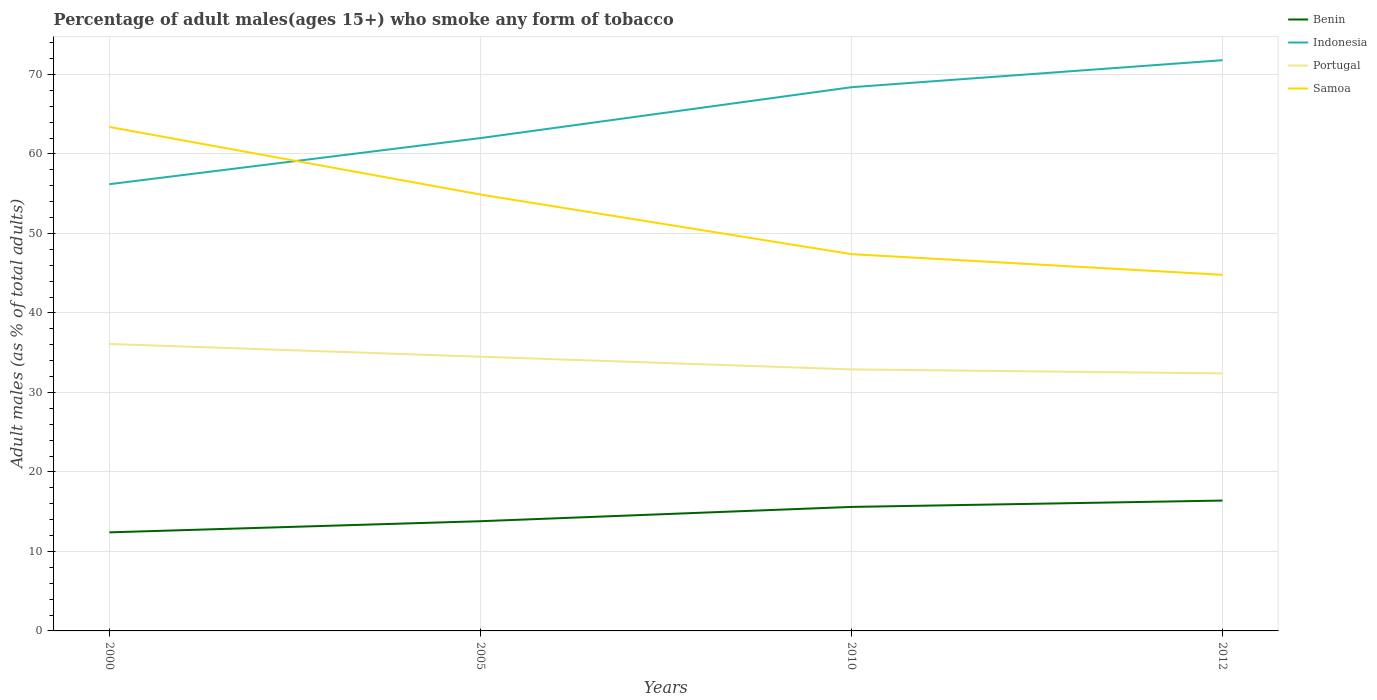Does the line corresponding to Portugal intersect with the line corresponding to Samoa?
Your response must be concise. No. Is the number of lines equal to the number of legend labels?
Your answer should be very brief. Yes. Across all years, what is the maximum percentage of adult males who smoke in Indonesia?
Offer a terse response. 56.2. In which year was the percentage of adult males who smoke in Benin maximum?
Make the answer very short. 2000. What is the total percentage of adult males who smoke in Indonesia in the graph?
Offer a very short reply. -12.2. What is the difference between the highest and the second highest percentage of adult males who smoke in Samoa?
Provide a short and direct response. 18.6. How many years are there in the graph?
Offer a very short reply. 4. What is the difference between two consecutive major ticks on the Y-axis?
Your answer should be very brief. 10. Are the values on the major ticks of Y-axis written in scientific E-notation?
Your answer should be very brief. No. What is the title of the graph?
Your response must be concise. Percentage of adult males(ages 15+) who smoke any form of tobacco. What is the label or title of the Y-axis?
Ensure brevity in your answer.  Adult males (as % of total adults). What is the Adult males (as % of total adults) in Benin in 2000?
Offer a terse response. 12.4. What is the Adult males (as % of total adults) in Indonesia in 2000?
Keep it short and to the point. 56.2. What is the Adult males (as % of total adults) in Portugal in 2000?
Provide a short and direct response. 36.1. What is the Adult males (as % of total adults) in Samoa in 2000?
Offer a very short reply. 63.4. What is the Adult males (as % of total adults) of Portugal in 2005?
Offer a terse response. 34.5. What is the Adult males (as % of total adults) in Samoa in 2005?
Keep it short and to the point. 54.9. What is the Adult males (as % of total adults) in Benin in 2010?
Provide a short and direct response. 15.6. What is the Adult males (as % of total adults) in Indonesia in 2010?
Give a very brief answer. 68.4. What is the Adult males (as % of total adults) in Portugal in 2010?
Make the answer very short. 32.9. What is the Adult males (as % of total adults) of Samoa in 2010?
Your answer should be compact. 47.4. What is the Adult males (as % of total adults) of Benin in 2012?
Provide a short and direct response. 16.4. What is the Adult males (as % of total adults) of Indonesia in 2012?
Your answer should be very brief. 71.8. What is the Adult males (as % of total adults) of Portugal in 2012?
Provide a succinct answer. 32.4. What is the Adult males (as % of total adults) of Samoa in 2012?
Offer a terse response. 44.8. Across all years, what is the maximum Adult males (as % of total adults) of Benin?
Provide a succinct answer. 16.4. Across all years, what is the maximum Adult males (as % of total adults) in Indonesia?
Keep it short and to the point. 71.8. Across all years, what is the maximum Adult males (as % of total adults) in Portugal?
Your answer should be compact. 36.1. Across all years, what is the maximum Adult males (as % of total adults) of Samoa?
Provide a succinct answer. 63.4. Across all years, what is the minimum Adult males (as % of total adults) in Indonesia?
Your answer should be very brief. 56.2. Across all years, what is the minimum Adult males (as % of total adults) of Portugal?
Keep it short and to the point. 32.4. Across all years, what is the minimum Adult males (as % of total adults) in Samoa?
Your answer should be compact. 44.8. What is the total Adult males (as % of total adults) in Benin in the graph?
Provide a short and direct response. 58.2. What is the total Adult males (as % of total adults) of Indonesia in the graph?
Your answer should be very brief. 258.4. What is the total Adult males (as % of total adults) of Portugal in the graph?
Your response must be concise. 135.9. What is the total Adult males (as % of total adults) in Samoa in the graph?
Offer a terse response. 210.5. What is the difference between the Adult males (as % of total adults) in Portugal in 2000 and that in 2005?
Offer a terse response. 1.6. What is the difference between the Adult males (as % of total adults) of Indonesia in 2000 and that in 2010?
Your response must be concise. -12.2. What is the difference between the Adult males (as % of total adults) in Portugal in 2000 and that in 2010?
Make the answer very short. 3.2. What is the difference between the Adult males (as % of total adults) in Samoa in 2000 and that in 2010?
Your answer should be very brief. 16. What is the difference between the Adult males (as % of total adults) in Benin in 2000 and that in 2012?
Your response must be concise. -4. What is the difference between the Adult males (as % of total adults) of Indonesia in 2000 and that in 2012?
Your answer should be very brief. -15.6. What is the difference between the Adult males (as % of total adults) of Portugal in 2000 and that in 2012?
Ensure brevity in your answer.  3.7. What is the difference between the Adult males (as % of total adults) of Benin in 2005 and that in 2010?
Give a very brief answer. -1.8. What is the difference between the Adult males (as % of total adults) in Portugal in 2005 and that in 2010?
Provide a short and direct response. 1.6. What is the difference between the Adult males (as % of total adults) in Samoa in 2005 and that in 2010?
Offer a terse response. 7.5. What is the difference between the Adult males (as % of total adults) in Benin in 2005 and that in 2012?
Your answer should be compact. -2.6. What is the difference between the Adult males (as % of total adults) of Indonesia in 2005 and that in 2012?
Keep it short and to the point. -9.8. What is the difference between the Adult males (as % of total adults) of Portugal in 2005 and that in 2012?
Your response must be concise. 2.1. What is the difference between the Adult males (as % of total adults) of Samoa in 2005 and that in 2012?
Make the answer very short. 10.1. What is the difference between the Adult males (as % of total adults) in Benin in 2010 and that in 2012?
Your answer should be very brief. -0.8. What is the difference between the Adult males (as % of total adults) of Portugal in 2010 and that in 2012?
Make the answer very short. 0.5. What is the difference between the Adult males (as % of total adults) in Samoa in 2010 and that in 2012?
Your answer should be compact. 2.6. What is the difference between the Adult males (as % of total adults) in Benin in 2000 and the Adult males (as % of total adults) in Indonesia in 2005?
Offer a very short reply. -49.6. What is the difference between the Adult males (as % of total adults) in Benin in 2000 and the Adult males (as % of total adults) in Portugal in 2005?
Give a very brief answer. -22.1. What is the difference between the Adult males (as % of total adults) of Benin in 2000 and the Adult males (as % of total adults) of Samoa in 2005?
Keep it short and to the point. -42.5. What is the difference between the Adult males (as % of total adults) of Indonesia in 2000 and the Adult males (as % of total adults) of Portugal in 2005?
Provide a short and direct response. 21.7. What is the difference between the Adult males (as % of total adults) in Indonesia in 2000 and the Adult males (as % of total adults) in Samoa in 2005?
Keep it short and to the point. 1.3. What is the difference between the Adult males (as % of total adults) of Portugal in 2000 and the Adult males (as % of total adults) of Samoa in 2005?
Offer a terse response. -18.8. What is the difference between the Adult males (as % of total adults) of Benin in 2000 and the Adult males (as % of total adults) of Indonesia in 2010?
Provide a succinct answer. -56. What is the difference between the Adult males (as % of total adults) in Benin in 2000 and the Adult males (as % of total adults) in Portugal in 2010?
Offer a terse response. -20.5. What is the difference between the Adult males (as % of total adults) of Benin in 2000 and the Adult males (as % of total adults) of Samoa in 2010?
Give a very brief answer. -35. What is the difference between the Adult males (as % of total adults) in Indonesia in 2000 and the Adult males (as % of total adults) in Portugal in 2010?
Offer a terse response. 23.3. What is the difference between the Adult males (as % of total adults) in Indonesia in 2000 and the Adult males (as % of total adults) in Samoa in 2010?
Your answer should be very brief. 8.8. What is the difference between the Adult males (as % of total adults) in Benin in 2000 and the Adult males (as % of total adults) in Indonesia in 2012?
Your answer should be very brief. -59.4. What is the difference between the Adult males (as % of total adults) of Benin in 2000 and the Adult males (as % of total adults) of Samoa in 2012?
Your answer should be very brief. -32.4. What is the difference between the Adult males (as % of total adults) of Indonesia in 2000 and the Adult males (as % of total adults) of Portugal in 2012?
Your answer should be compact. 23.8. What is the difference between the Adult males (as % of total adults) in Indonesia in 2000 and the Adult males (as % of total adults) in Samoa in 2012?
Your answer should be compact. 11.4. What is the difference between the Adult males (as % of total adults) in Benin in 2005 and the Adult males (as % of total adults) in Indonesia in 2010?
Offer a very short reply. -54.6. What is the difference between the Adult males (as % of total adults) of Benin in 2005 and the Adult males (as % of total adults) of Portugal in 2010?
Keep it short and to the point. -19.1. What is the difference between the Adult males (as % of total adults) of Benin in 2005 and the Adult males (as % of total adults) of Samoa in 2010?
Make the answer very short. -33.6. What is the difference between the Adult males (as % of total adults) of Indonesia in 2005 and the Adult males (as % of total adults) of Portugal in 2010?
Your answer should be compact. 29.1. What is the difference between the Adult males (as % of total adults) of Indonesia in 2005 and the Adult males (as % of total adults) of Samoa in 2010?
Provide a short and direct response. 14.6. What is the difference between the Adult males (as % of total adults) in Benin in 2005 and the Adult males (as % of total adults) in Indonesia in 2012?
Keep it short and to the point. -58. What is the difference between the Adult males (as % of total adults) in Benin in 2005 and the Adult males (as % of total adults) in Portugal in 2012?
Give a very brief answer. -18.6. What is the difference between the Adult males (as % of total adults) in Benin in 2005 and the Adult males (as % of total adults) in Samoa in 2012?
Offer a very short reply. -31. What is the difference between the Adult males (as % of total adults) in Indonesia in 2005 and the Adult males (as % of total adults) in Portugal in 2012?
Your response must be concise. 29.6. What is the difference between the Adult males (as % of total adults) of Portugal in 2005 and the Adult males (as % of total adults) of Samoa in 2012?
Provide a succinct answer. -10.3. What is the difference between the Adult males (as % of total adults) in Benin in 2010 and the Adult males (as % of total adults) in Indonesia in 2012?
Make the answer very short. -56.2. What is the difference between the Adult males (as % of total adults) in Benin in 2010 and the Adult males (as % of total adults) in Portugal in 2012?
Your answer should be very brief. -16.8. What is the difference between the Adult males (as % of total adults) in Benin in 2010 and the Adult males (as % of total adults) in Samoa in 2012?
Keep it short and to the point. -29.2. What is the difference between the Adult males (as % of total adults) in Indonesia in 2010 and the Adult males (as % of total adults) in Portugal in 2012?
Provide a short and direct response. 36. What is the difference between the Adult males (as % of total adults) in Indonesia in 2010 and the Adult males (as % of total adults) in Samoa in 2012?
Keep it short and to the point. 23.6. What is the average Adult males (as % of total adults) of Benin per year?
Your response must be concise. 14.55. What is the average Adult males (as % of total adults) of Indonesia per year?
Your response must be concise. 64.6. What is the average Adult males (as % of total adults) of Portugal per year?
Ensure brevity in your answer.  33.98. What is the average Adult males (as % of total adults) in Samoa per year?
Provide a succinct answer. 52.62. In the year 2000, what is the difference between the Adult males (as % of total adults) of Benin and Adult males (as % of total adults) of Indonesia?
Provide a succinct answer. -43.8. In the year 2000, what is the difference between the Adult males (as % of total adults) in Benin and Adult males (as % of total adults) in Portugal?
Make the answer very short. -23.7. In the year 2000, what is the difference between the Adult males (as % of total adults) in Benin and Adult males (as % of total adults) in Samoa?
Your answer should be very brief. -51. In the year 2000, what is the difference between the Adult males (as % of total adults) in Indonesia and Adult males (as % of total adults) in Portugal?
Make the answer very short. 20.1. In the year 2000, what is the difference between the Adult males (as % of total adults) in Indonesia and Adult males (as % of total adults) in Samoa?
Offer a terse response. -7.2. In the year 2000, what is the difference between the Adult males (as % of total adults) in Portugal and Adult males (as % of total adults) in Samoa?
Ensure brevity in your answer.  -27.3. In the year 2005, what is the difference between the Adult males (as % of total adults) of Benin and Adult males (as % of total adults) of Indonesia?
Provide a succinct answer. -48.2. In the year 2005, what is the difference between the Adult males (as % of total adults) in Benin and Adult males (as % of total adults) in Portugal?
Your answer should be compact. -20.7. In the year 2005, what is the difference between the Adult males (as % of total adults) of Benin and Adult males (as % of total adults) of Samoa?
Offer a terse response. -41.1. In the year 2005, what is the difference between the Adult males (as % of total adults) in Indonesia and Adult males (as % of total adults) in Samoa?
Offer a terse response. 7.1. In the year 2005, what is the difference between the Adult males (as % of total adults) of Portugal and Adult males (as % of total adults) of Samoa?
Offer a very short reply. -20.4. In the year 2010, what is the difference between the Adult males (as % of total adults) of Benin and Adult males (as % of total adults) of Indonesia?
Give a very brief answer. -52.8. In the year 2010, what is the difference between the Adult males (as % of total adults) in Benin and Adult males (as % of total adults) in Portugal?
Keep it short and to the point. -17.3. In the year 2010, what is the difference between the Adult males (as % of total adults) of Benin and Adult males (as % of total adults) of Samoa?
Offer a very short reply. -31.8. In the year 2010, what is the difference between the Adult males (as % of total adults) in Indonesia and Adult males (as % of total adults) in Portugal?
Provide a short and direct response. 35.5. In the year 2010, what is the difference between the Adult males (as % of total adults) in Portugal and Adult males (as % of total adults) in Samoa?
Your answer should be very brief. -14.5. In the year 2012, what is the difference between the Adult males (as % of total adults) of Benin and Adult males (as % of total adults) of Indonesia?
Your response must be concise. -55.4. In the year 2012, what is the difference between the Adult males (as % of total adults) of Benin and Adult males (as % of total adults) of Portugal?
Ensure brevity in your answer.  -16. In the year 2012, what is the difference between the Adult males (as % of total adults) in Benin and Adult males (as % of total adults) in Samoa?
Give a very brief answer. -28.4. In the year 2012, what is the difference between the Adult males (as % of total adults) of Indonesia and Adult males (as % of total adults) of Portugal?
Provide a succinct answer. 39.4. In the year 2012, what is the difference between the Adult males (as % of total adults) of Indonesia and Adult males (as % of total adults) of Samoa?
Offer a very short reply. 27. What is the ratio of the Adult males (as % of total adults) in Benin in 2000 to that in 2005?
Provide a short and direct response. 0.9. What is the ratio of the Adult males (as % of total adults) in Indonesia in 2000 to that in 2005?
Offer a very short reply. 0.91. What is the ratio of the Adult males (as % of total adults) in Portugal in 2000 to that in 2005?
Your answer should be compact. 1.05. What is the ratio of the Adult males (as % of total adults) in Samoa in 2000 to that in 2005?
Provide a short and direct response. 1.15. What is the ratio of the Adult males (as % of total adults) of Benin in 2000 to that in 2010?
Ensure brevity in your answer.  0.79. What is the ratio of the Adult males (as % of total adults) in Indonesia in 2000 to that in 2010?
Make the answer very short. 0.82. What is the ratio of the Adult males (as % of total adults) in Portugal in 2000 to that in 2010?
Offer a very short reply. 1.1. What is the ratio of the Adult males (as % of total adults) of Samoa in 2000 to that in 2010?
Your response must be concise. 1.34. What is the ratio of the Adult males (as % of total adults) in Benin in 2000 to that in 2012?
Your answer should be very brief. 0.76. What is the ratio of the Adult males (as % of total adults) of Indonesia in 2000 to that in 2012?
Make the answer very short. 0.78. What is the ratio of the Adult males (as % of total adults) of Portugal in 2000 to that in 2012?
Provide a short and direct response. 1.11. What is the ratio of the Adult males (as % of total adults) in Samoa in 2000 to that in 2012?
Offer a very short reply. 1.42. What is the ratio of the Adult males (as % of total adults) in Benin in 2005 to that in 2010?
Keep it short and to the point. 0.88. What is the ratio of the Adult males (as % of total adults) of Indonesia in 2005 to that in 2010?
Keep it short and to the point. 0.91. What is the ratio of the Adult males (as % of total adults) in Portugal in 2005 to that in 2010?
Provide a succinct answer. 1.05. What is the ratio of the Adult males (as % of total adults) of Samoa in 2005 to that in 2010?
Give a very brief answer. 1.16. What is the ratio of the Adult males (as % of total adults) of Benin in 2005 to that in 2012?
Your answer should be compact. 0.84. What is the ratio of the Adult males (as % of total adults) in Indonesia in 2005 to that in 2012?
Provide a short and direct response. 0.86. What is the ratio of the Adult males (as % of total adults) in Portugal in 2005 to that in 2012?
Offer a very short reply. 1.06. What is the ratio of the Adult males (as % of total adults) in Samoa in 2005 to that in 2012?
Keep it short and to the point. 1.23. What is the ratio of the Adult males (as % of total adults) in Benin in 2010 to that in 2012?
Provide a short and direct response. 0.95. What is the ratio of the Adult males (as % of total adults) in Indonesia in 2010 to that in 2012?
Your response must be concise. 0.95. What is the ratio of the Adult males (as % of total adults) of Portugal in 2010 to that in 2012?
Offer a terse response. 1.02. What is the ratio of the Adult males (as % of total adults) of Samoa in 2010 to that in 2012?
Your answer should be very brief. 1.06. What is the difference between the highest and the second highest Adult males (as % of total adults) in Benin?
Ensure brevity in your answer.  0.8. What is the difference between the highest and the second highest Adult males (as % of total adults) of Samoa?
Provide a short and direct response. 8.5. What is the difference between the highest and the lowest Adult males (as % of total adults) of Samoa?
Offer a terse response. 18.6. 